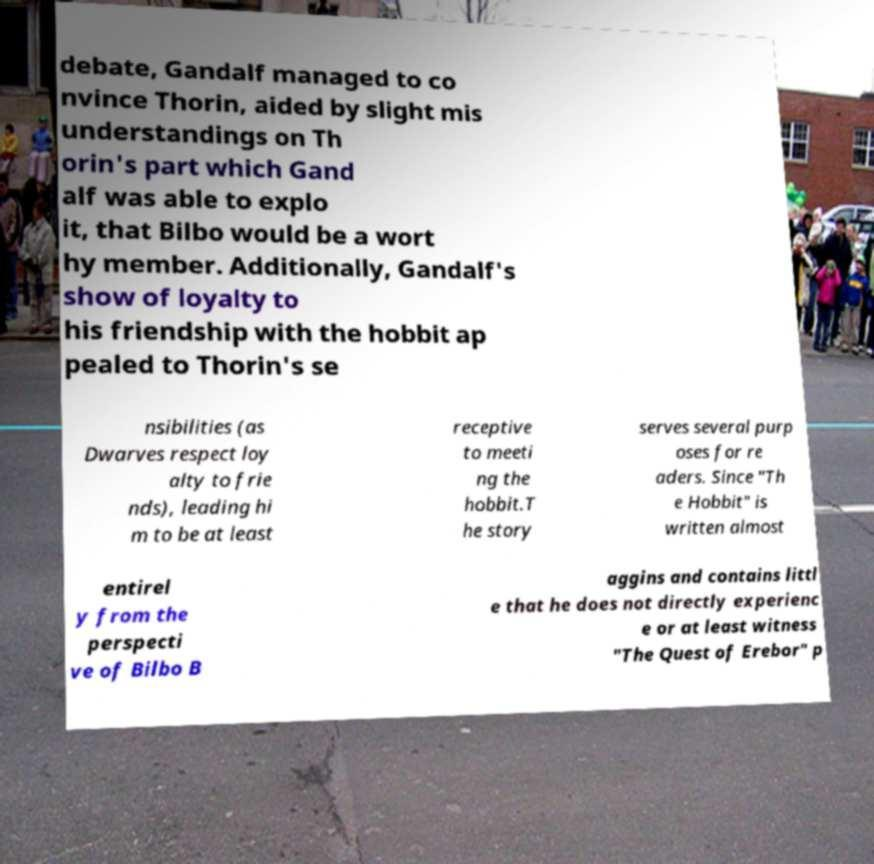Could you assist in decoding the text presented in this image and type it out clearly? debate, Gandalf managed to co nvince Thorin, aided by slight mis understandings on Th orin's part which Gand alf was able to explo it, that Bilbo would be a wort hy member. Additionally, Gandalf's show of loyalty to his friendship with the hobbit ap pealed to Thorin's se nsibilities (as Dwarves respect loy alty to frie nds), leading hi m to be at least receptive to meeti ng the hobbit.T he story serves several purp oses for re aders. Since "Th e Hobbit" is written almost entirel y from the perspecti ve of Bilbo B aggins and contains littl e that he does not directly experienc e or at least witness "The Quest of Erebor" p 